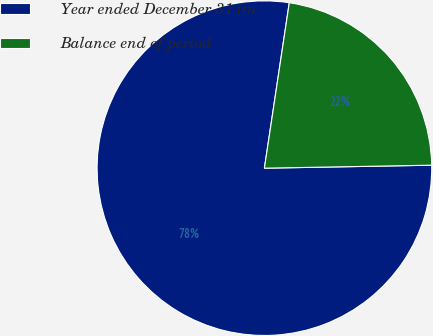Convert chart to OTSL. <chart><loc_0><loc_0><loc_500><loc_500><pie_chart><fcel>Year ended December 31 (in<fcel>Balance end of period<nl><fcel>77.66%<fcel>22.34%<nl></chart> 